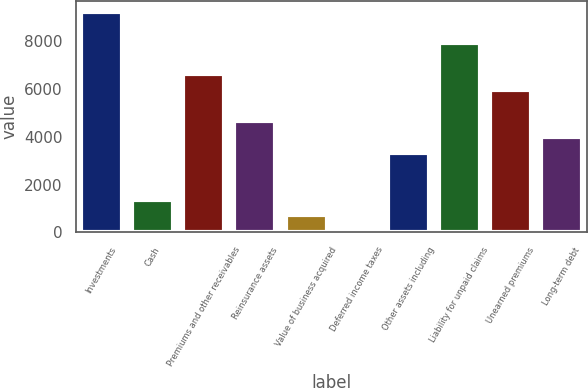Convert chart. <chart><loc_0><loc_0><loc_500><loc_500><bar_chart><fcel>Investments<fcel>Cash<fcel>Premiums and other receivables<fcel>Reinsurance assets<fcel>Value of business acquired<fcel>Deferred income taxes<fcel>Other assets including<fcel>Liability for unpaid claims<fcel>Unearned premiums<fcel>Long-term debt<nl><fcel>9233<fcel>1373<fcel>6613<fcel>4648<fcel>718<fcel>63<fcel>3338<fcel>7923<fcel>5958<fcel>3993<nl></chart> 